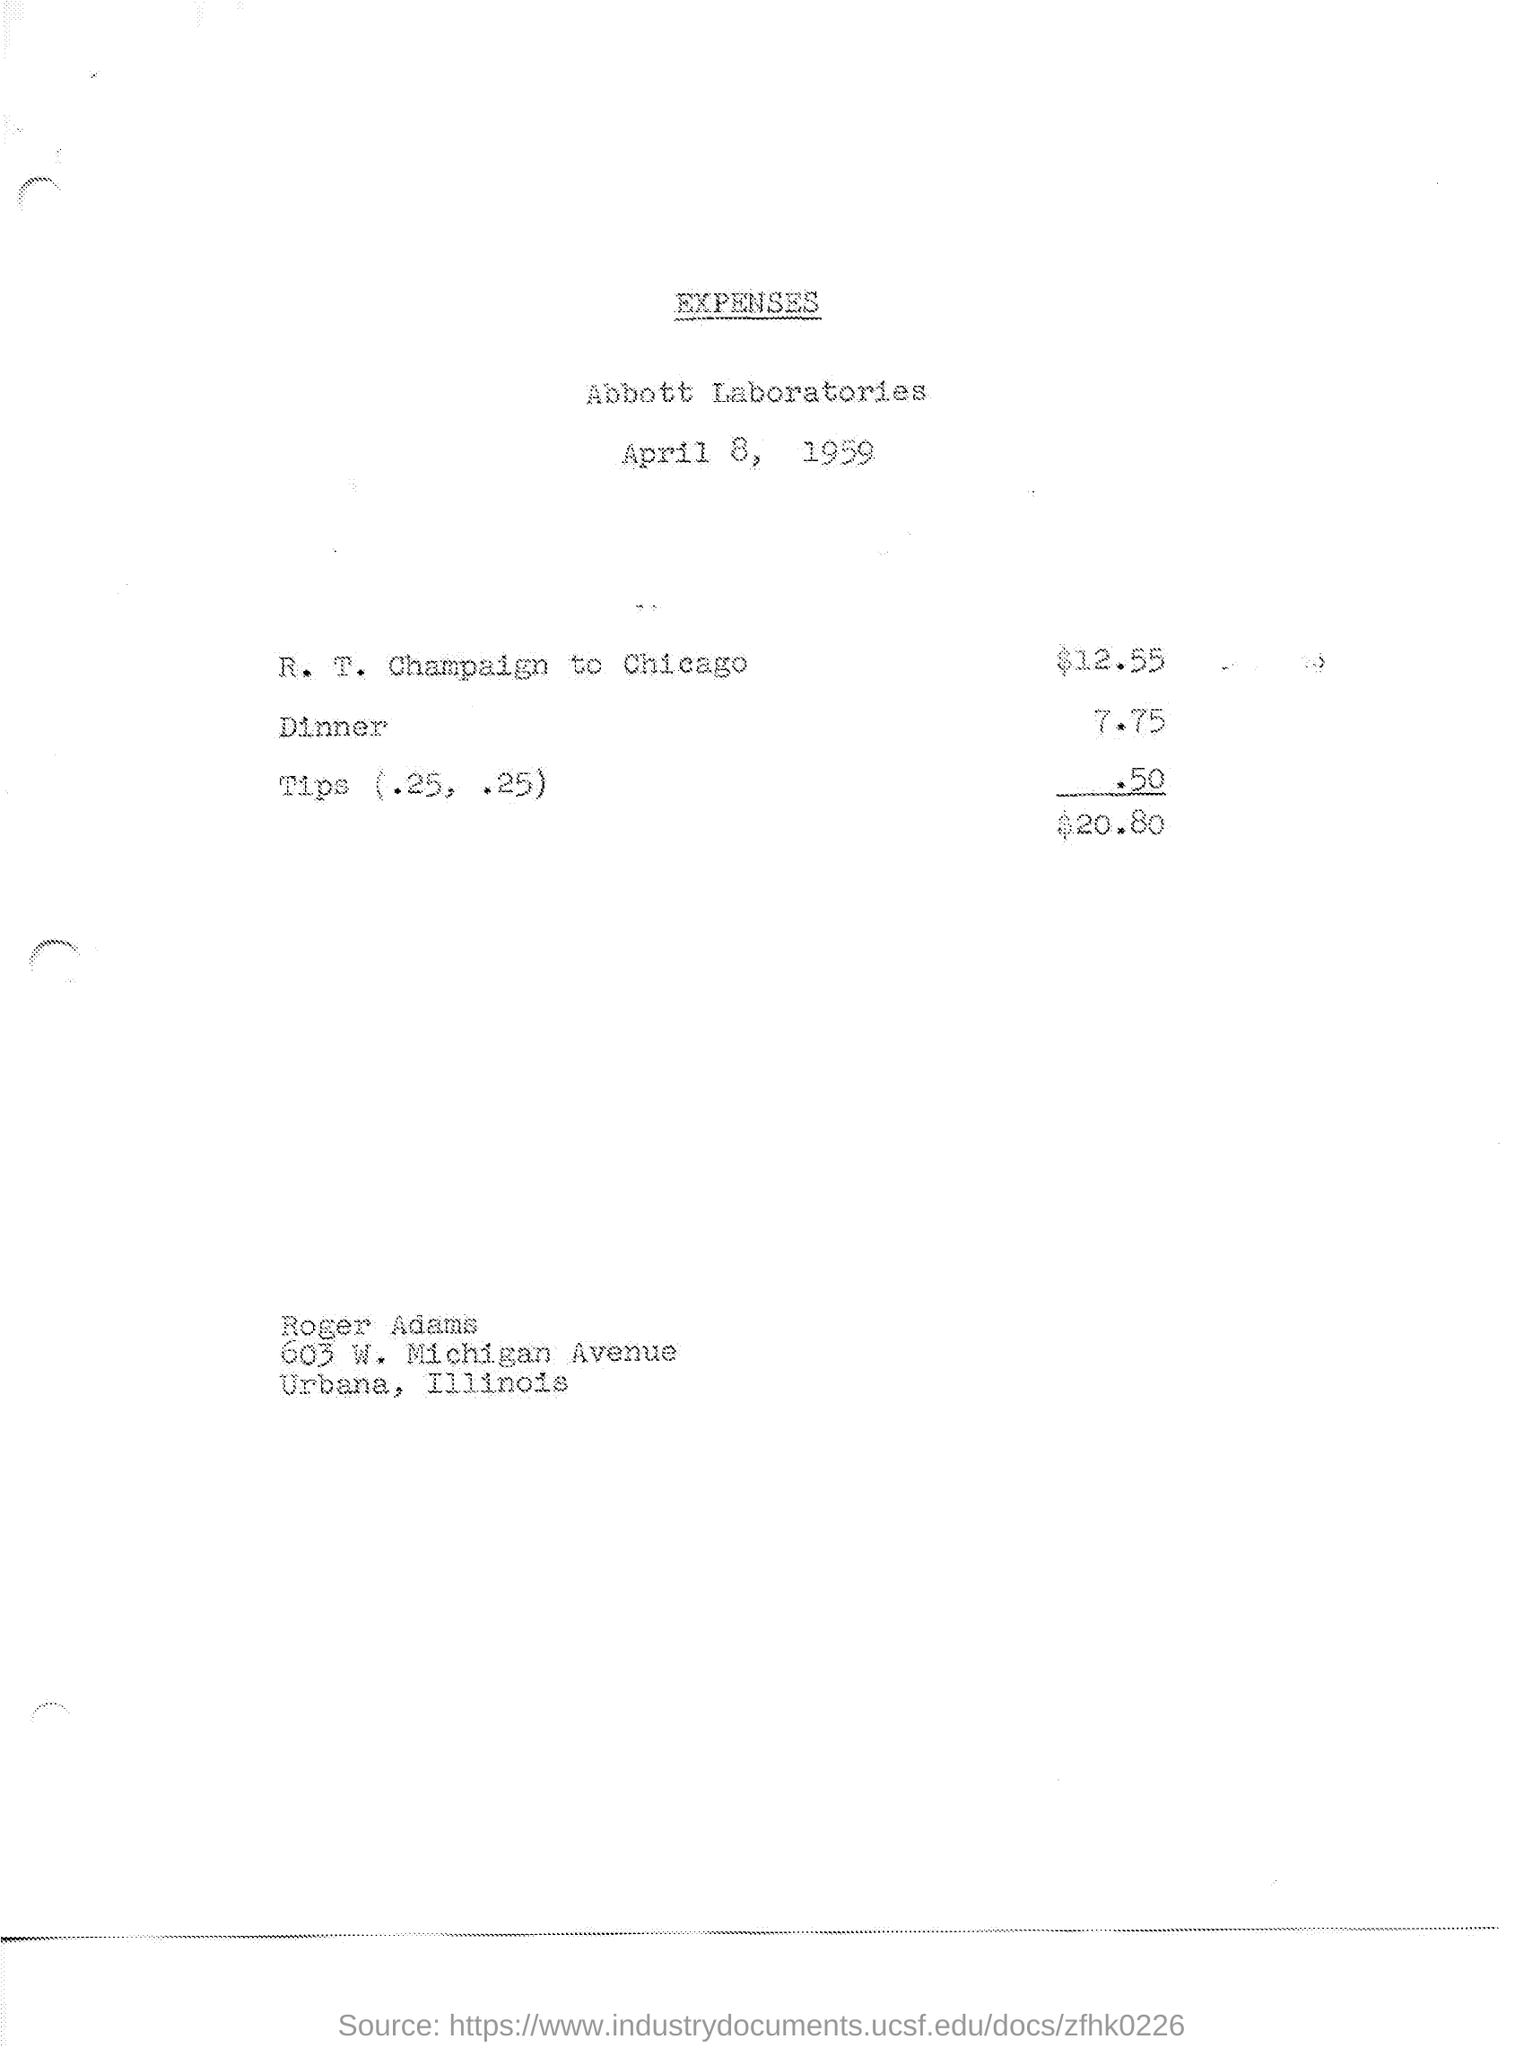Can you describe the purpose of this document? This document appears to be an expense sheet from Abbott Laboratories for a trip from R. T. Champaign to Chicago, including costs for dinner and tips. It likely served for reimbursement or accounting purposes. 